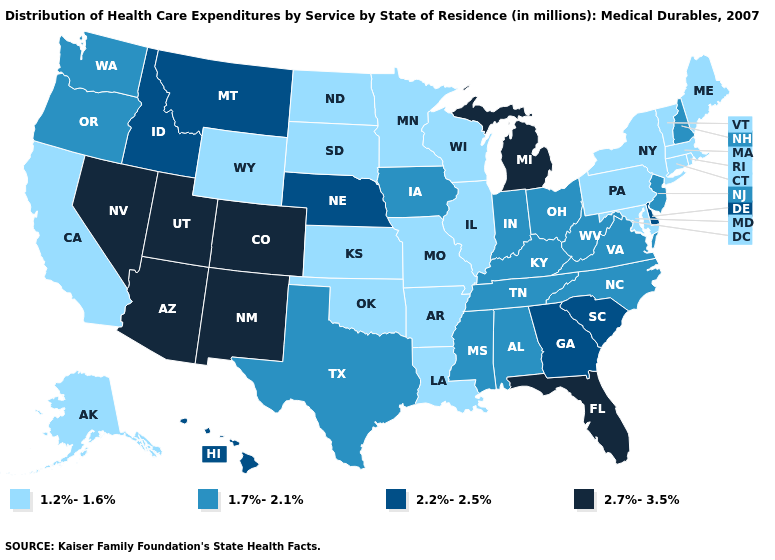Name the states that have a value in the range 1.7%-2.1%?
Write a very short answer. Alabama, Indiana, Iowa, Kentucky, Mississippi, New Hampshire, New Jersey, North Carolina, Ohio, Oregon, Tennessee, Texas, Virginia, Washington, West Virginia. Does South Carolina have the same value as Maine?
Concise answer only. No. What is the lowest value in states that border Delaware?
Keep it brief. 1.2%-1.6%. What is the highest value in states that border Utah?
Answer briefly. 2.7%-3.5%. Among the states that border North Carolina , does South Carolina have the lowest value?
Quick response, please. No. Among the states that border Texas , does Arkansas have the highest value?
Short answer required. No. Which states have the highest value in the USA?
Give a very brief answer. Arizona, Colorado, Florida, Michigan, Nevada, New Mexico, Utah. Does the map have missing data?
Concise answer only. No. Does Hawaii have the highest value in the USA?
Answer briefly. No. What is the highest value in the USA?
Keep it brief. 2.7%-3.5%. Does New Jersey have the lowest value in the Northeast?
Concise answer only. No. Does Connecticut have the same value as Colorado?
Answer briefly. No. Does Montana have the same value as Virginia?
Short answer required. No. What is the lowest value in states that border Washington?
Write a very short answer. 1.7%-2.1%. Among the states that border California , does Oregon have the lowest value?
Write a very short answer. Yes. 